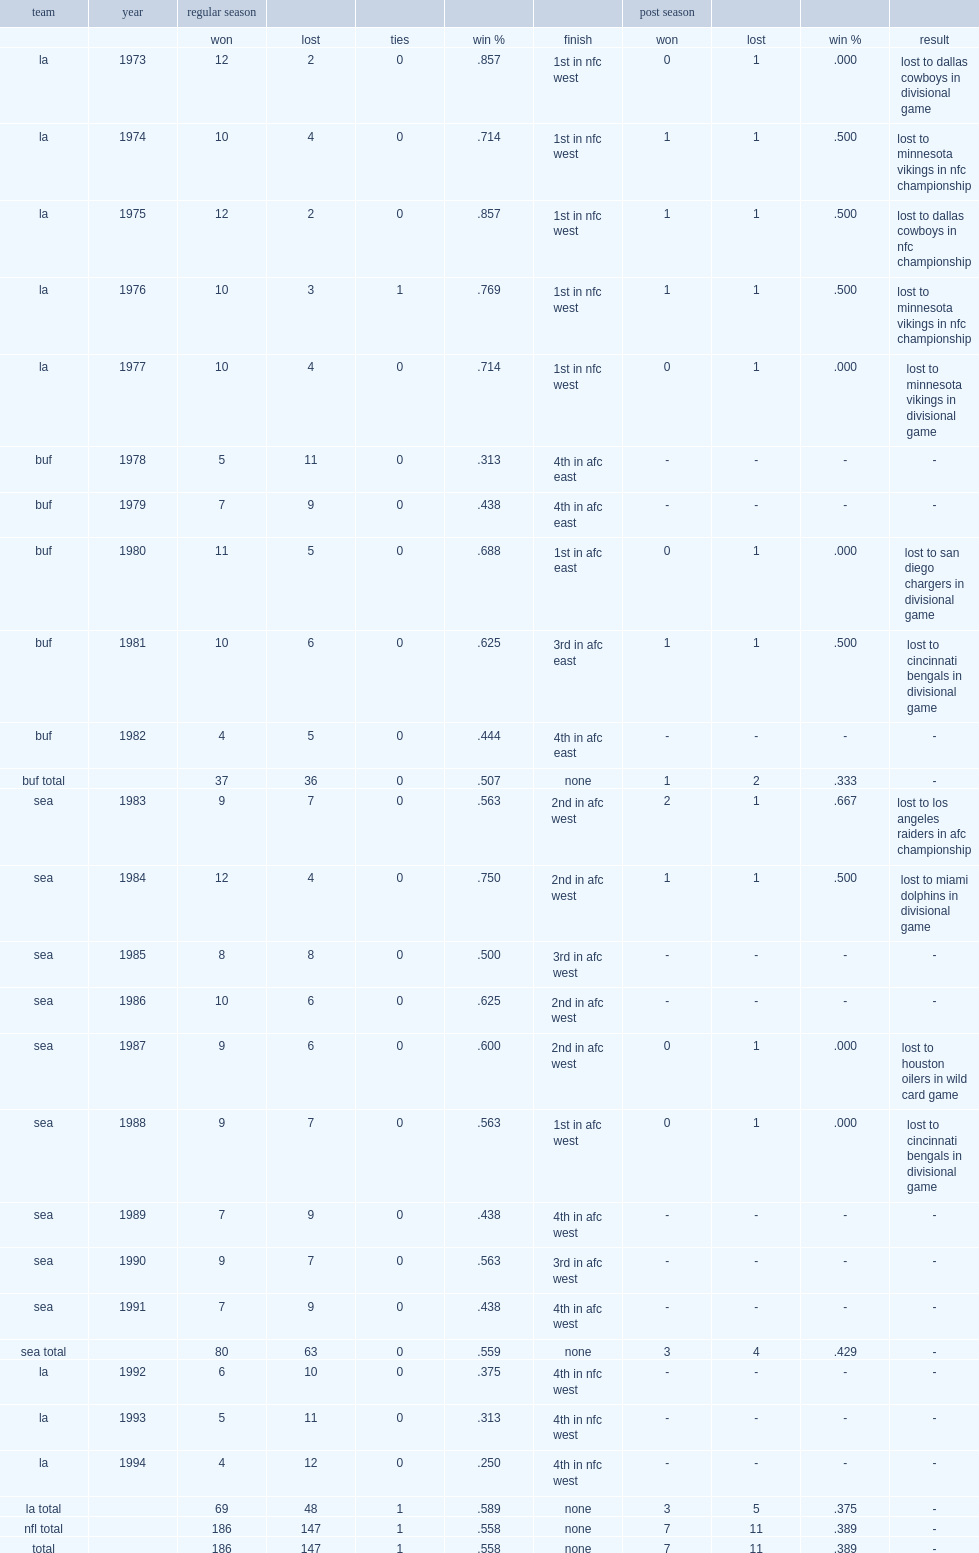What was the tie record of knox totally? 1.0. 